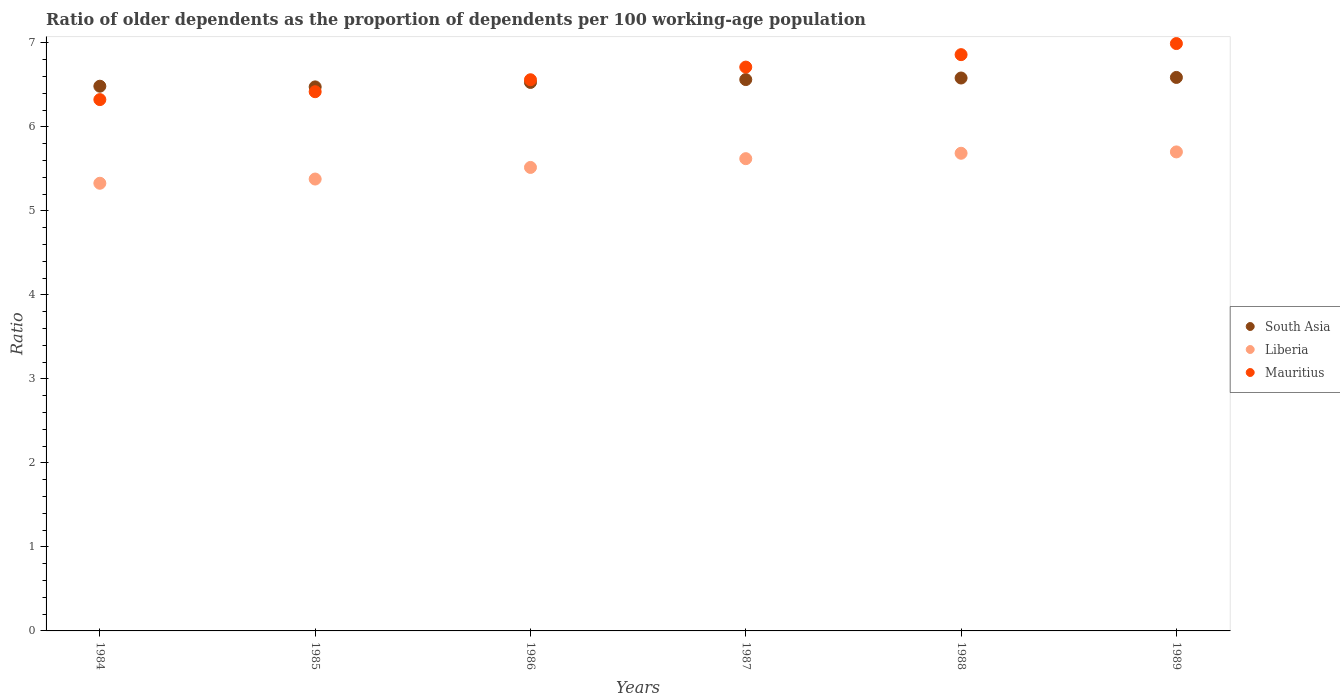How many different coloured dotlines are there?
Give a very brief answer. 3. Is the number of dotlines equal to the number of legend labels?
Keep it short and to the point. Yes. What is the age dependency ratio(old) in South Asia in 1985?
Give a very brief answer. 6.48. Across all years, what is the maximum age dependency ratio(old) in Liberia?
Make the answer very short. 5.7. Across all years, what is the minimum age dependency ratio(old) in South Asia?
Offer a terse response. 6.48. What is the total age dependency ratio(old) in Mauritius in the graph?
Keep it short and to the point. 39.87. What is the difference between the age dependency ratio(old) in South Asia in 1984 and that in 1986?
Provide a succinct answer. -0.04. What is the difference between the age dependency ratio(old) in South Asia in 1984 and the age dependency ratio(old) in Mauritius in 1986?
Your response must be concise. -0.08. What is the average age dependency ratio(old) in Liberia per year?
Ensure brevity in your answer.  5.54. In the year 1986, what is the difference between the age dependency ratio(old) in South Asia and age dependency ratio(old) in Mauritius?
Offer a terse response. -0.03. What is the ratio of the age dependency ratio(old) in Liberia in 1984 to that in 1988?
Provide a succinct answer. 0.94. Is the difference between the age dependency ratio(old) in South Asia in 1984 and 1985 greater than the difference between the age dependency ratio(old) in Mauritius in 1984 and 1985?
Offer a very short reply. Yes. What is the difference between the highest and the second highest age dependency ratio(old) in South Asia?
Your answer should be very brief. 0.01. What is the difference between the highest and the lowest age dependency ratio(old) in Mauritius?
Provide a succinct answer. 0.67. Is the sum of the age dependency ratio(old) in Mauritius in 1985 and 1987 greater than the maximum age dependency ratio(old) in South Asia across all years?
Your answer should be compact. Yes. Is it the case that in every year, the sum of the age dependency ratio(old) in Mauritius and age dependency ratio(old) in Liberia  is greater than the age dependency ratio(old) in South Asia?
Provide a short and direct response. Yes. Does the age dependency ratio(old) in Liberia monotonically increase over the years?
Your answer should be very brief. Yes. Is the age dependency ratio(old) in South Asia strictly less than the age dependency ratio(old) in Liberia over the years?
Provide a short and direct response. No. How many years are there in the graph?
Your answer should be very brief. 6. What is the difference between two consecutive major ticks on the Y-axis?
Your answer should be very brief. 1. Are the values on the major ticks of Y-axis written in scientific E-notation?
Provide a succinct answer. No. Does the graph contain any zero values?
Give a very brief answer. No. Where does the legend appear in the graph?
Make the answer very short. Center right. How many legend labels are there?
Keep it short and to the point. 3. What is the title of the graph?
Give a very brief answer. Ratio of older dependents as the proportion of dependents per 100 working-age population. What is the label or title of the X-axis?
Provide a short and direct response. Years. What is the label or title of the Y-axis?
Ensure brevity in your answer.  Ratio. What is the Ratio in South Asia in 1984?
Your response must be concise. 6.49. What is the Ratio in Liberia in 1984?
Make the answer very short. 5.33. What is the Ratio of Mauritius in 1984?
Provide a succinct answer. 6.33. What is the Ratio of South Asia in 1985?
Keep it short and to the point. 6.48. What is the Ratio of Liberia in 1985?
Provide a short and direct response. 5.38. What is the Ratio of Mauritius in 1985?
Offer a very short reply. 6.42. What is the Ratio in South Asia in 1986?
Your answer should be compact. 6.53. What is the Ratio in Liberia in 1986?
Provide a succinct answer. 5.52. What is the Ratio of Mauritius in 1986?
Give a very brief answer. 6.56. What is the Ratio of South Asia in 1987?
Provide a short and direct response. 6.56. What is the Ratio of Liberia in 1987?
Offer a very short reply. 5.62. What is the Ratio in Mauritius in 1987?
Your answer should be very brief. 6.71. What is the Ratio in South Asia in 1988?
Offer a terse response. 6.58. What is the Ratio of Liberia in 1988?
Give a very brief answer. 5.69. What is the Ratio of Mauritius in 1988?
Your answer should be compact. 6.86. What is the Ratio in South Asia in 1989?
Ensure brevity in your answer.  6.59. What is the Ratio of Liberia in 1989?
Ensure brevity in your answer.  5.7. What is the Ratio in Mauritius in 1989?
Ensure brevity in your answer.  6.99. Across all years, what is the maximum Ratio of South Asia?
Your answer should be compact. 6.59. Across all years, what is the maximum Ratio in Liberia?
Your answer should be compact. 5.7. Across all years, what is the maximum Ratio of Mauritius?
Ensure brevity in your answer.  6.99. Across all years, what is the minimum Ratio of South Asia?
Your response must be concise. 6.48. Across all years, what is the minimum Ratio in Liberia?
Offer a terse response. 5.33. Across all years, what is the minimum Ratio of Mauritius?
Your response must be concise. 6.33. What is the total Ratio in South Asia in the graph?
Your answer should be very brief. 39.23. What is the total Ratio in Liberia in the graph?
Your answer should be compact. 33.24. What is the total Ratio in Mauritius in the graph?
Give a very brief answer. 39.87. What is the difference between the Ratio in South Asia in 1984 and that in 1985?
Provide a succinct answer. 0.01. What is the difference between the Ratio of Liberia in 1984 and that in 1985?
Your answer should be very brief. -0.05. What is the difference between the Ratio of Mauritius in 1984 and that in 1985?
Give a very brief answer. -0.09. What is the difference between the Ratio in South Asia in 1984 and that in 1986?
Ensure brevity in your answer.  -0.04. What is the difference between the Ratio in Liberia in 1984 and that in 1986?
Keep it short and to the point. -0.19. What is the difference between the Ratio in Mauritius in 1984 and that in 1986?
Your answer should be very brief. -0.24. What is the difference between the Ratio of South Asia in 1984 and that in 1987?
Offer a terse response. -0.08. What is the difference between the Ratio of Liberia in 1984 and that in 1987?
Keep it short and to the point. -0.29. What is the difference between the Ratio of Mauritius in 1984 and that in 1987?
Ensure brevity in your answer.  -0.39. What is the difference between the Ratio of South Asia in 1984 and that in 1988?
Your response must be concise. -0.1. What is the difference between the Ratio in Liberia in 1984 and that in 1988?
Give a very brief answer. -0.36. What is the difference between the Ratio of Mauritius in 1984 and that in 1988?
Offer a very short reply. -0.54. What is the difference between the Ratio in South Asia in 1984 and that in 1989?
Offer a terse response. -0.1. What is the difference between the Ratio in Liberia in 1984 and that in 1989?
Ensure brevity in your answer.  -0.37. What is the difference between the Ratio in Mauritius in 1984 and that in 1989?
Offer a very short reply. -0.67. What is the difference between the Ratio of South Asia in 1985 and that in 1986?
Your answer should be compact. -0.05. What is the difference between the Ratio of Liberia in 1985 and that in 1986?
Keep it short and to the point. -0.14. What is the difference between the Ratio of Mauritius in 1985 and that in 1986?
Make the answer very short. -0.14. What is the difference between the Ratio in South Asia in 1985 and that in 1987?
Provide a succinct answer. -0.09. What is the difference between the Ratio of Liberia in 1985 and that in 1987?
Your answer should be compact. -0.24. What is the difference between the Ratio in Mauritius in 1985 and that in 1987?
Your answer should be very brief. -0.29. What is the difference between the Ratio in South Asia in 1985 and that in 1988?
Keep it short and to the point. -0.11. What is the difference between the Ratio of Liberia in 1985 and that in 1988?
Offer a terse response. -0.31. What is the difference between the Ratio of Mauritius in 1985 and that in 1988?
Make the answer very short. -0.44. What is the difference between the Ratio in South Asia in 1985 and that in 1989?
Ensure brevity in your answer.  -0.11. What is the difference between the Ratio of Liberia in 1985 and that in 1989?
Give a very brief answer. -0.32. What is the difference between the Ratio of Mauritius in 1985 and that in 1989?
Offer a very short reply. -0.57. What is the difference between the Ratio of South Asia in 1986 and that in 1987?
Your answer should be very brief. -0.03. What is the difference between the Ratio in Liberia in 1986 and that in 1987?
Offer a very short reply. -0.1. What is the difference between the Ratio in Mauritius in 1986 and that in 1987?
Your answer should be very brief. -0.15. What is the difference between the Ratio in South Asia in 1986 and that in 1988?
Provide a succinct answer. -0.05. What is the difference between the Ratio in Liberia in 1986 and that in 1988?
Ensure brevity in your answer.  -0.17. What is the difference between the Ratio of Mauritius in 1986 and that in 1988?
Provide a succinct answer. -0.3. What is the difference between the Ratio of South Asia in 1986 and that in 1989?
Your response must be concise. -0.06. What is the difference between the Ratio of Liberia in 1986 and that in 1989?
Offer a terse response. -0.18. What is the difference between the Ratio in Mauritius in 1986 and that in 1989?
Offer a very short reply. -0.43. What is the difference between the Ratio in South Asia in 1987 and that in 1988?
Provide a short and direct response. -0.02. What is the difference between the Ratio of Liberia in 1987 and that in 1988?
Your answer should be very brief. -0.06. What is the difference between the Ratio of Mauritius in 1987 and that in 1988?
Keep it short and to the point. -0.15. What is the difference between the Ratio of South Asia in 1987 and that in 1989?
Ensure brevity in your answer.  -0.03. What is the difference between the Ratio in Liberia in 1987 and that in 1989?
Your answer should be compact. -0.08. What is the difference between the Ratio of Mauritius in 1987 and that in 1989?
Provide a short and direct response. -0.28. What is the difference between the Ratio in South Asia in 1988 and that in 1989?
Ensure brevity in your answer.  -0.01. What is the difference between the Ratio of Liberia in 1988 and that in 1989?
Give a very brief answer. -0.02. What is the difference between the Ratio in Mauritius in 1988 and that in 1989?
Provide a short and direct response. -0.13. What is the difference between the Ratio of South Asia in 1984 and the Ratio of Liberia in 1985?
Your answer should be compact. 1.11. What is the difference between the Ratio of South Asia in 1984 and the Ratio of Mauritius in 1985?
Your answer should be compact. 0.07. What is the difference between the Ratio of Liberia in 1984 and the Ratio of Mauritius in 1985?
Your answer should be very brief. -1.09. What is the difference between the Ratio of South Asia in 1984 and the Ratio of Liberia in 1986?
Provide a short and direct response. 0.97. What is the difference between the Ratio in South Asia in 1984 and the Ratio in Mauritius in 1986?
Provide a succinct answer. -0.08. What is the difference between the Ratio of Liberia in 1984 and the Ratio of Mauritius in 1986?
Ensure brevity in your answer.  -1.23. What is the difference between the Ratio in South Asia in 1984 and the Ratio in Liberia in 1987?
Your answer should be very brief. 0.86. What is the difference between the Ratio in South Asia in 1984 and the Ratio in Mauritius in 1987?
Keep it short and to the point. -0.23. What is the difference between the Ratio in Liberia in 1984 and the Ratio in Mauritius in 1987?
Offer a very short reply. -1.38. What is the difference between the Ratio in South Asia in 1984 and the Ratio in Liberia in 1988?
Keep it short and to the point. 0.8. What is the difference between the Ratio in South Asia in 1984 and the Ratio in Mauritius in 1988?
Make the answer very short. -0.38. What is the difference between the Ratio of Liberia in 1984 and the Ratio of Mauritius in 1988?
Keep it short and to the point. -1.53. What is the difference between the Ratio in South Asia in 1984 and the Ratio in Liberia in 1989?
Provide a short and direct response. 0.78. What is the difference between the Ratio in South Asia in 1984 and the Ratio in Mauritius in 1989?
Your answer should be compact. -0.51. What is the difference between the Ratio of Liberia in 1984 and the Ratio of Mauritius in 1989?
Keep it short and to the point. -1.66. What is the difference between the Ratio of South Asia in 1985 and the Ratio of Liberia in 1986?
Your answer should be very brief. 0.96. What is the difference between the Ratio in South Asia in 1985 and the Ratio in Mauritius in 1986?
Provide a succinct answer. -0.09. What is the difference between the Ratio of Liberia in 1985 and the Ratio of Mauritius in 1986?
Offer a very short reply. -1.18. What is the difference between the Ratio of South Asia in 1985 and the Ratio of Liberia in 1987?
Your answer should be very brief. 0.85. What is the difference between the Ratio of South Asia in 1985 and the Ratio of Mauritius in 1987?
Provide a short and direct response. -0.24. What is the difference between the Ratio in Liberia in 1985 and the Ratio in Mauritius in 1987?
Ensure brevity in your answer.  -1.33. What is the difference between the Ratio in South Asia in 1985 and the Ratio in Liberia in 1988?
Give a very brief answer. 0.79. What is the difference between the Ratio in South Asia in 1985 and the Ratio in Mauritius in 1988?
Make the answer very short. -0.38. What is the difference between the Ratio of Liberia in 1985 and the Ratio of Mauritius in 1988?
Ensure brevity in your answer.  -1.48. What is the difference between the Ratio in South Asia in 1985 and the Ratio in Liberia in 1989?
Your answer should be compact. 0.77. What is the difference between the Ratio of South Asia in 1985 and the Ratio of Mauritius in 1989?
Your response must be concise. -0.52. What is the difference between the Ratio of Liberia in 1985 and the Ratio of Mauritius in 1989?
Offer a very short reply. -1.61. What is the difference between the Ratio in South Asia in 1986 and the Ratio in Liberia in 1987?
Provide a short and direct response. 0.91. What is the difference between the Ratio of South Asia in 1986 and the Ratio of Mauritius in 1987?
Offer a terse response. -0.18. What is the difference between the Ratio in Liberia in 1986 and the Ratio in Mauritius in 1987?
Provide a succinct answer. -1.19. What is the difference between the Ratio in South Asia in 1986 and the Ratio in Liberia in 1988?
Make the answer very short. 0.84. What is the difference between the Ratio in South Asia in 1986 and the Ratio in Mauritius in 1988?
Your answer should be compact. -0.33. What is the difference between the Ratio of Liberia in 1986 and the Ratio of Mauritius in 1988?
Your answer should be compact. -1.34. What is the difference between the Ratio in South Asia in 1986 and the Ratio in Liberia in 1989?
Offer a terse response. 0.83. What is the difference between the Ratio of South Asia in 1986 and the Ratio of Mauritius in 1989?
Ensure brevity in your answer.  -0.46. What is the difference between the Ratio of Liberia in 1986 and the Ratio of Mauritius in 1989?
Your response must be concise. -1.47. What is the difference between the Ratio of South Asia in 1987 and the Ratio of Liberia in 1988?
Your answer should be compact. 0.88. What is the difference between the Ratio of South Asia in 1987 and the Ratio of Mauritius in 1988?
Provide a short and direct response. -0.3. What is the difference between the Ratio of Liberia in 1987 and the Ratio of Mauritius in 1988?
Ensure brevity in your answer.  -1.24. What is the difference between the Ratio of South Asia in 1987 and the Ratio of Liberia in 1989?
Your answer should be very brief. 0.86. What is the difference between the Ratio of South Asia in 1987 and the Ratio of Mauritius in 1989?
Your answer should be compact. -0.43. What is the difference between the Ratio in Liberia in 1987 and the Ratio in Mauritius in 1989?
Provide a succinct answer. -1.37. What is the difference between the Ratio in South Asia in 1988 and the Ratio in Liberia in 1989?
Provide a short and direct response. 0.88. What is the difference between the Ratio of South Asia in 1988 and the Ratio of Mauritius in 1989?
Your response must be concise. -0.41. What is the difference between the Ratio of Liberia in 1988 and the Ratio of Mauritius in 1989?
Give a very brief answer. -1.31. What is the average Ratio of South Asia per year?
Offer a very short reply. 6.54. What is the average Ratio of Liberia per year?
Offer a very short reply. 5.54. What is the average Ratio in Mauritius per year?
Provide a short and direct response. 6.65. In the year 1984, what is the difference between the Ratio of South Asia and Ratio of Liberia?
Offer a very short reply. 1.16. In the year 1984, what is the difference between the Ratio of South Asia and Ratio of Mauritius?
Provide a short and direct response. 0.16. In the year 1984, what is the difference between the Ratio in Liberia and Ratio in Mauritius?
Offer a very short reply. -1. In the year 1985, what is the difference between the Ratio in South Asia and Ratio in Liberia?
Provide a succinct answer. 1.1. In the year 1985, what is the difference between the Ratio in South Asia and Ratio in Mauritius?
Your answer should be very brief. 0.06. In the year 1985, what is the difference between the Ratio of Liberia and Ratio of Mauritius?
Make the answer very short. -1.04. In the year 1986, what is the difference between the Ratio in South Asia and Ratio in Liberia?
Give a very brief answer. 1.01. In the year 1986, what is the difference between the Ratio in South Asia and Ratio in Mauritius?
Ensure brevity in your answer.  -0.03. In the year 1986, what is the difference between the Ratio of Liberia and Ratio of Mauritius?
Give a very brief answer. -1.04. In the year 1987, what is the difference between the Ratio in South Asia and Ratio in Liberia?
Give a very brief answer. 0.94. In the year 1987, what is the difference between the Ratio in South Asia and Ratio in Mauritius?
Provide a short and direct response. -0.15. In the year 1987, what is the difference between the Ratio in Liberia and Ratio in Mauritius?
Offer a very short reply. -1.09. In the year 1988, what is the difference between the Ratio of South Asia and Ratio of Liberia?
Ensure brevity in your answer.  0.9. In the year 1988, what is the difference between the Ratio in South Asia and Ratio in Mauritius?
Your answer should be very brief. -0.28. In the year 1988, what is the difference between the Ratio in Liberia and Ratio in Mauritius?
Your response must be concise. -1.17. In the year 1989, what is the difference between the Ratio in South Asia and Ratio in Liberia?
Your answer should be very brief. 0.89. In the year 1989, what is the difference between the Ratio in South Asia and Ratio in Mauritius?
Keep it short and to the point. -0.4. In the year 1989, what is the difference between the Ratio in Liberia and Ratio in Mauritius?
Provide a succinct answer. -1.29. What is the ratio of the Ratio in South Asia in 1984 to that in 1985?
Ensure brevity in your answer.  1. What is the ratio of the Ratio in Mauritius in 1984 to that in 1985?
Your answer should be compact. 0.99. What is the ratio of the Ratio in South Asia in 1984 to that in 1986?
Make the answer very short. 0.99. What is the ratio of the Ratio of Liberia in 1984 to that in 1986?
Ensure brevity in your answer.  0.97. What is the ratio of the Ratio of South Asia in 1984 to that in 1987?
Your response must be concise. 0.99. What is the ratio of the Ratio of Liberia in 1984 to that in 1987?
Make the answer very short. 0.95. What is the ratio of the Ratio in Mauritius in 1984 to that in 1987?
Keep it short and to the point. 0.94. What is the ratio of the Ratio of South Asia in 1984 to that in 1988?
Keep it short and to the point. 0.99. What is the ratio of the Ratio of Liberia in 1984 to that in 1988?
Your response must be concise. 0.94. What is the ratio of the Ratio in Mauritius in 1984 to that in 1988?
Give a very brief answer. 0.92. What is the ratio of the Ratio in South Asia in 1984 to that in 1989?
Ensure brevity in your answer.  0.98. What is the ratio of the Ratio of Liberia in 1984 to that in 1989?
Provide a succinct answer. 0.93. What is the ratio of the Ratio of Mauritius in 1984 to that in 1989?
Offer a very short reply. 0.9. What is the ratio of the Ratio of South Asia in 1985 to that in 1986?
Give a very brief answer. 0.99. What is the ratio of the Ratio in Liberia in 1985 to that in 1986?
Ensure brevity in your answer.  0.97. What is the ratio of the Ratio in Mauritius in 1985 to that in 1986?
Make the answer very short. 0.98. What is the ratio of the Ratio in South Asia in 1985 to that in 1987?
Provide a succinct answer. 0.99. What is the ratio of the Ratio of Liberia in 1985 to that in 1987?
Your response must be concise. 0.96. What is the ratio of the Ratio of Mauritius in 1985 to that in 1987?
Make the answer very short. 0.96. What is the ratio of the Ratio in South Asia in 1985 to that in 1988?
Offer a terse response. 0.98. What is the ratio of the Ratio of Liberia in 1985 to that in 1988?
Offer a very short reply. 0.95. What is the ratio of the Ratio in Mauritius in 1985 to that in 1988?
Your answer should be compact. 0.94. What is the ratio of the Ratio in South Asia in 1985 to that in 1989?
Offer a terse response. 0.98. What is the ratio of the Ratio of Liberia in 1985 to that in 1989?
Your answer should be compact. 0.94. What is the ratio of the Ratio in Mauritius in 1985 to that in 1989?
Your answer should be compact. 0.92. What is the ratio of the Ratio in Liberia in 1986 to that in 1987?
Your response must be concise. 0.98. What is the ratio of the Ratio of Mauritius in 1986 to that in 1987?
Make the answer very short. 0.98. What is the ratio of the Ratio in South Asia in 1986 to that in 1988?
Keep it short and to the point. 0.99. What is the ratio of the Ratio of Liberia in 1986 to that in 1988?
Provide a succinct answer. 0.97. What is the ratio of the Ratio of Mauritius in 1986 to that in 1988?
Offer a terse response. 0.96. What is the ratio of the Ratio in South Asia in 1986 to that in 1989?
Offer a terse response. 0.99. What is the ratio of the Ratio of Liberia in 1986 to that in 1989?
Make the answer very short. 0.97. What is the ratio of the Ratio of Mauritius in 1986 to that in 1989?
Your response must be concise. 0.94. What is the ratio of the Ratio of South Asia in 1987 to that in 1988?
Make the answer very short. 1. What is the ratio of the Ratio in Liberia in 1987 to that in 1988?
Offer a terse response. 0.99. What is the ratio of the Ratio of Mauritius in 1987 to that in 1988?
Your response must be concise. 0.98. What is the ratio of the Ratio of South Asia in 1987 to that in 1989?
Make the answer very short. 1. What is the ratio of the Ratio of Liberia in 1987 to that in 1989?
Keep it short and to the point. 0.99. What is the ratio of the Ratio of Mauritius in 1987 to that in 1989?
Make the answer very short. 0.96. What is the ratio of the Ratio in South Asia in 1988 to that in 1989?
Your answer should be very brief. 1. What is the ratio of the Ratio in Mauritius in 1988 to that in 1989?
Make the answer very short. 0.98. What is the difference between the highest and the second highest Ratio of South Asia?
Your response must be concise. 0.01. What is the difference between the highest and the second highest Ratio in Liberia?
Ensure brevity in your answer.  0.02. What is the difference between the highest and the second highest Ratio of Mauritius?
Provide a short and direct response. 0.13. What is the difference between the highest and the lowest Ratio in South Asia?
Your answer should be compact. 0.11. What is the difference between the highest and the lowest Ratio of Liberia?
Offer a very short reply. 0.37. What is the difference between the highest and the lowest Ratio in Mauritius?
Your response must be concise. 0.67. 